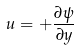<formula> <loc_0><loc_0><loc_500><loc_500>u = + \frac { \partial \psi } { \partial y }</formula> 